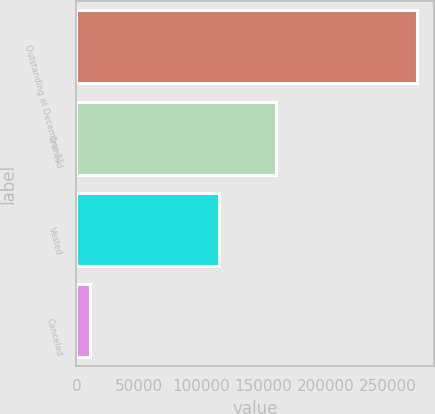<chart> <loc_0><loc_0><loc_500><loc_500><bar_chart><fcel>Outstanding at December 31<fcel>Granted<fcel>Vested<fcel>Canceled<nl><fcel>273387<fcel>160427<fcel>114509<fcel>10575<nl></chart> 